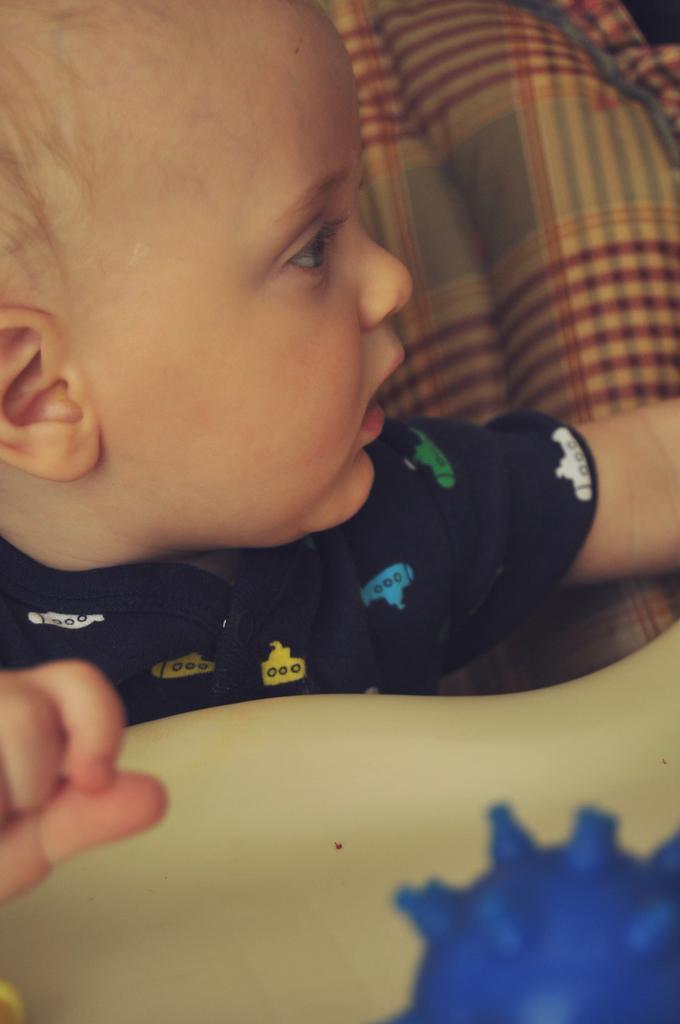In one or two sentences, can you explain what this image depicts? In the picture there is a baby and there is some cloth behind the baby. 